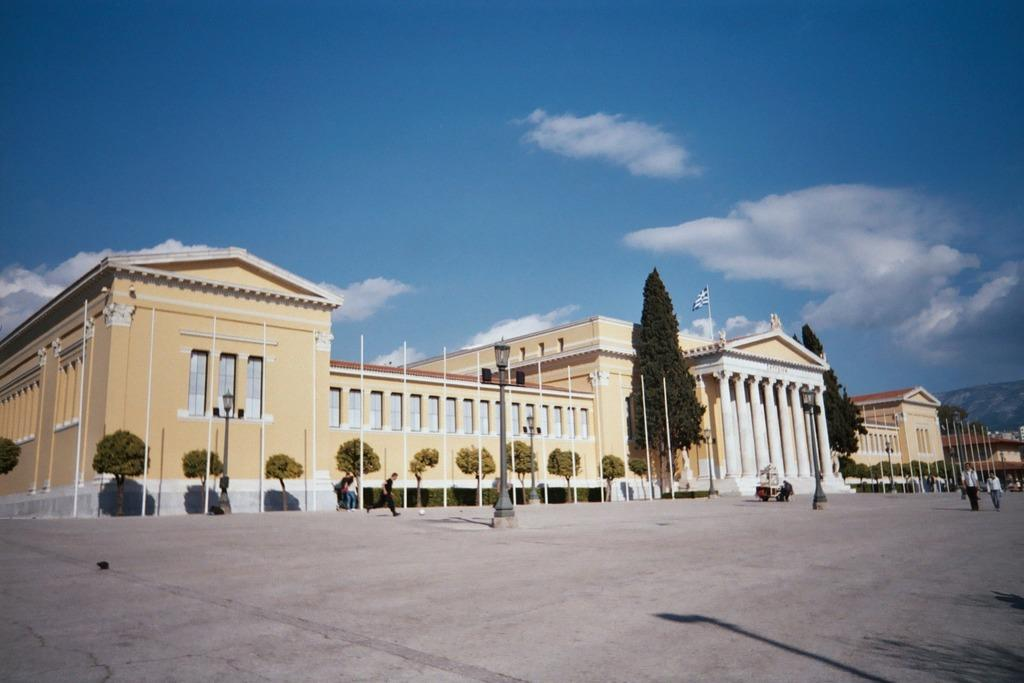What type of structures can be seen in the image? There are buildings in the image. What other natural elements are present in the image? There are trees in the image. What are the people in the image doing? There are people walking in the image. What object can be seen on the ground in the image? There is a ball in the image. What type of vertical structures are present in the image? There are poles in the image. What type of lighting is present in the image? There is a pole light in the image. How would you describe the sky in the image? The sky is blue and cloudy in the image. Can you tell me how many ants are crawling on the ball in the image? There are no ants present in the image; the ball is not crawling with ants. What type of stitch is used to create the clouds in the image? The clouds in the image are not created using stitches; they are natural formations in the sky. 